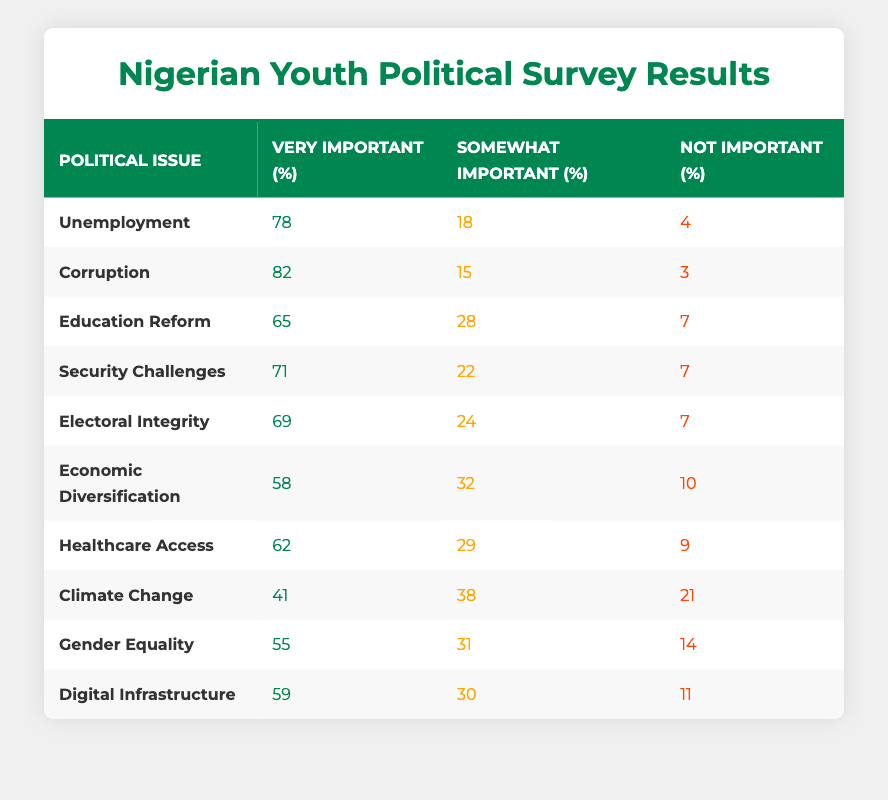What is the percentage of youth who find unemployment very important? In the table, the row for "Unemployment" indicates that 78% of youth find it very important.
Answer: 78% Which political issue has the highest percentage of youth considering it very important? By scanning the "Very Important (%)" column, "Corruption" stands out with 82%, the highest among all issues listed.
Answer: Corruption What is the sum of the percentages of youth who consider healthcare access very important and somewhat important? For "Healthcare Access", 62% find it very important, and 29% find it somewhat important. Adding these values gives 62 + 29 = 91%.
Answer: 91% Is it true that a higher percentage of youth find climate change very important compared to gender equality? The percentage for "Climate Change" as very important is 41%, while for "Gender Equality", it is 55%. Therefore, it is false that more youth find climate change very important than gender equality.
Answer: No What is the average percentage of youth who considered economic diversification and healthcare access as very important? The percentages for economic diversification and healthcare access are 58% and 62%, respectively. To find the average, we add 58 + 62 = 120 and then divide by 2, which gives an average of 60%.
Answer: 60% Which issue has a higher total of 'very important' and 'somewhat important' percentages, electoral integrity or education reform? Electoral integrity has 69% (very important) + 24% (somewhat important) = 93%. Education reform has 65% + 28% = 93%. Both issues have the same total percentage.
Answer: They are equal How many political issues have a percentage of youth considering them not important greater than 10%? Checking the 'Not Important (%)' column, only "Climate Change" (21%) and "Economic Diversification" (10%) have percentages greater than 10%. Thus, there are two issues.
Answer: Two What percentage of youth find corruption either very important or somewhat important? For "Corruption", the percentage of those who find it very important is 82% and somewhat important is 15%. Summing these gives 82 + 15 = 97%.
Answer: 97% 